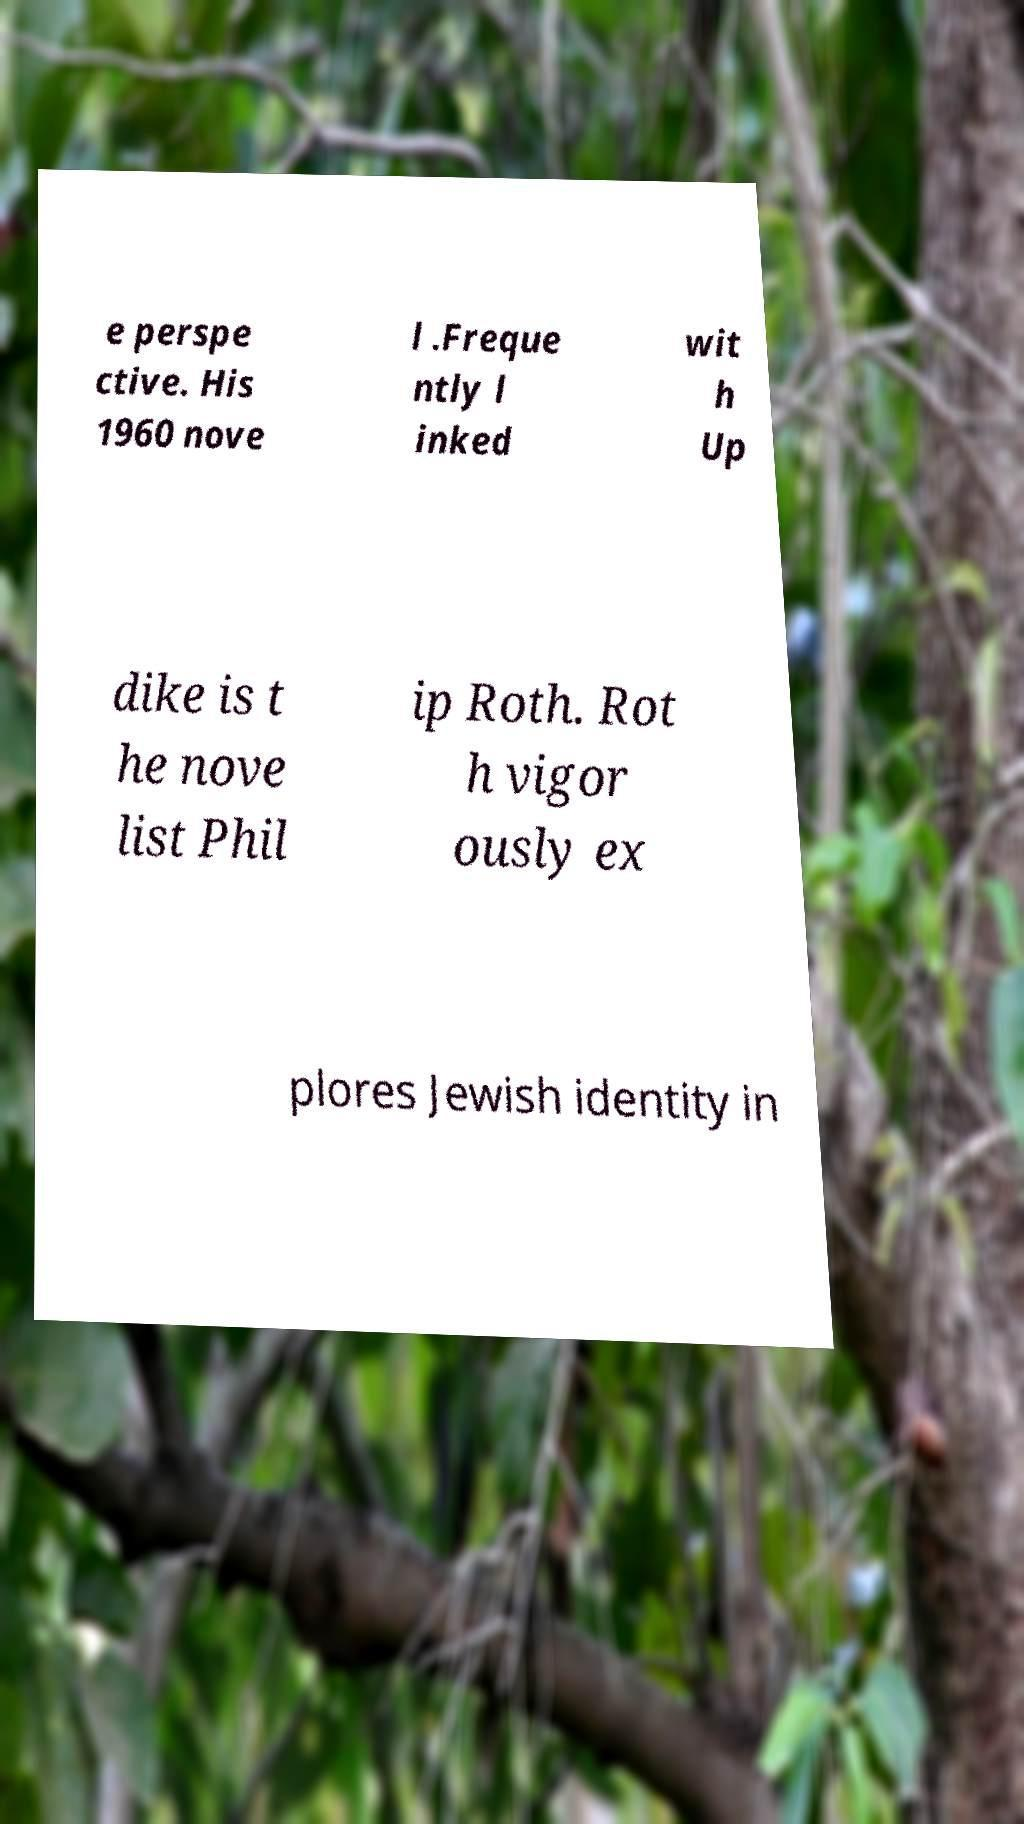I need the written content from this picture converted into text. Can you do that? e perspe ctive. His 1960 nove l .Freque ntly l inked wit h Up dike is t he nove list Phil ip Roth. Rot h vigor ously ex plores Jewish identity in 